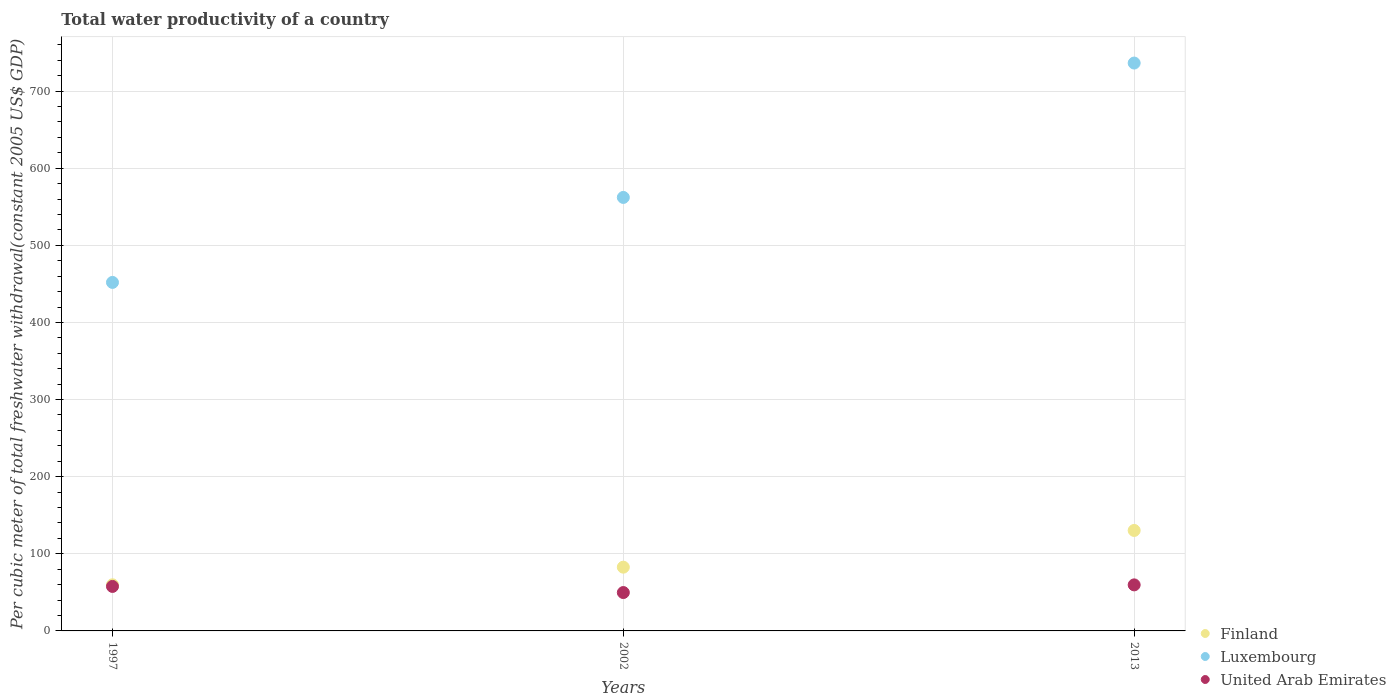What is the total water productivity in Luxembourg in 1997?
Offer a very short reply. 451.9. Across all years, what is the maximum total water productivity in Luxembourg?
Your response must be concise. 736.35. Across all years, what is the minimum total water productivity in Luxembourg?
Offer a terse response. 451.9. In which year was the total water productivity in Finland minimum?
Provide a short and direct response. 1997. What is the total total water productivity in Luxembourg in the graph?
Your response must be concise. 1750.35. What is the difference between the total water productivity in Luxembourg in 1997 and that in 2013?
Provide a short and direct response. -284.44. What is the difference between the total water productivity in Finland in 2013 and the total water productivity in United Arab Emirates in 1997?
Keep it short and to the point. 72.58. What is the average total water productivity in Luxembourg per year?
Provide a short and direct response. 583.45. In the year 1997, what is the difference between the total water productivity in Finland and total water productivity in United Arab Emirates?
Offer a terse response. 2.12. What is the ratio of the total water productivity in Luxembourg in 1997 to that in 2002?
Give a very brief answer. 0.8. What is the difference between the highest and the second highest total water productivity in Luxembourg?
Your answer should be very brief. 174.24. What is the difference between the highest and the lowest total water productivity in United Arab Emirates?
Offer a very short reply. 9.94. Is the sum of the total water productivity in Finland in 2002 and 2013 greater than the maximum total water productivity in United Arab Emirates across all years?
Keep it short and to the point. Yes. Is the total water productivity in Finland strictly greater than the total water productivity in United Arab Emirates over the years?
Your answer should be very brief. Yes. How many dotlines are there?
Ensure brevity in your answer.  3. What is the difference between two consecutive major ticks on the Y-axis?
Your response must be concise. 100. Does the graph contain grids?
Keep it short and to the point. Yes. How many legend labels are there?
Ensure brevity in your answer.  3. How are the legend labels stacked?
Provide a succinct answer. Vertical. What is the title of the graph?
Keep it short and to the point. Total water productivity of a country. Does "Uruguay" appear as one of the legend labels in the graph?
Ensure brevity in your answer.  No. What is the label or title of the X-axis?
Ensure brevity in your answer.  Years. What is the label or title of the Y-axis?
Your answer should be very brief. Per cubic meter of total freshwater withdrawal(constant 2005 US$ GDP). What is the Per cubic meter of total freshwater withdrawal(constant 2005 US$ GDP) of Finland in 1997?
Offer a terse response. 59.81. What is the Per cubic meter of total freshwater withdrawal(constant 2005 US$ GDP) in Luxembourg in 1997?
Your response must be concise. 451.9. What is the Per cubic meter of total freshwater withdrawal(constant 2005 US$ GDP) in United Arab Emirates in 1997?
Your response must be concise. 57.69. What is the Per cubic meter of total freshwater withdrawal(constant 2005 US$ GDP) in Finland in 2002?
Offer a very short reply. 82.67. What is the Per cubic meter of total freshwater withdrawal(constant 2005 US$ GDP) in Luxembourg in 2002?
Offer a terse response. 562.1. What is the Per cubic meter of total freshwater withdrawal(constant 2005 US$ GDP) of United Arab Emirates in 2002?
Offer a terse response. 49.76. What is the Per cubic meter of total freshwater withdrawal(constant 2005 US$ GDP) in Finland in 2013?
Your answer should be compact. 130.27. What is the Per cubic meter of total freshwater withdrawal(constant 2005 US$ GDP) in Luxembourg in 2013?
Your answer should be compact. 736.35. What is the Per cubic meter of total freshwater withdrawal(constant 2005 US$ GDP) in United Arab Emirates in 2013?
Ensure brevity in your answer.  59.7. Across all years, what is the maximum Per cubic meter of total freshwater withdrawal(constant 2005 US$ GDP) in Finland?
Provide a succinct answer. 130.27. Across all years, what is the maximum Per cubic meter of total freshwater withdrawal(constant 2005 US$ GDP) in Luxembourg?
Your response must be concise. 736.35. Across all years, what is the maximum Per cubic meter of total freshwater withdrawal(constant 2005 US$ GDP) of United Arab Emirates?
Your response must be concise. 59.7. Across all years, what is the minimum Per cubic meter of total freshwater withdrawal(constant 2005 US$ GDP) in Finland?
Your answer should be compact. 59.81. Across all years, what is the minimum Per cubic meter of total freshwater withdrawal(constant 2005 US$ GDP) in Luxembourg?
Make the answer very short. 451.9. Across all years, what is the minimum Per cubic meter of total freshwater withdrawal(constant 2005 US$ GDP) of United Arab Emirates?
Keep it short and to the point. 49.76. What is the total Per cubic meter of total freshwater withdrawal(constant 2005 US$ GDP) of Finland in the graph?
Your response must be concise. 272.75. What is the total Per cubic meter of total freshwater withdrawal(constant 2005 US$ GDP) in Luxembourg in the graph?
Your response must be concise. 1750.35. What is the total Per cubic meter of total freshwater withdrawal(constant 2005 US$ GDP) of United Arab Emirates in the graph?
Make the answer very short. 167.14. What is the difference between the Per cubic meter of total freshwater withdrawal(constant 2005 US$ GDP) of Finland in 1997 and that in 2002?
Your response must be concise. -22.86. What is the difference between the Per cubic meter of total freshwater withdrawal(constant 2005 US$ GDP) in Luxembourg in 1997 and that in 2002?
Your answer should be compact. -110.2. What is the difference between the Per cubic meter of total freshwater withdrawal(constant 2005 US$ GDP) in United Arab Emirates in 1997 and that in 2002?
Provide a short and direct response. 7.93. What is the difference between the Per cubic meter of total freshwater withdrawal(constant 2005 US$ GDP) in Finland in 1997 and that in 2013?
Keep it short and to the point. -70.46. What is the difference between the Per cubic meter of total freshwater withdrawal(constant 2005 US$ GDP) of Luxembourg in 1997 and that in 2013?
Make the answer very short. -284.44. What is the difference between the Per cubic meter of total freshwater withdrawal(constant 2005 US$ GDP) in United Arab Emirates in 1997 and that in 2013?
Provide a short and direct response. -2.01. What is the difference between the Per cubic meter of total freshwater withdrawal(constant 2005 US$ GDP) of Finland in 2002 and that in 2013?
Offer a very short reply. -47.61. What is the difference between the Per cubic meter of total freshwater withdrawal(constant 2005 US$ GDP) of Luxembourg in 2002 and that in 2013?
Your answer should be very brief. -174.24. What is the difference between the Per cubic meter of total freshwater withdrawal(constant 2005 US$ GDP) in United Arab Emirates in 2002 and that in 2013?
Offer a very short reply. -9.94. What is the difference between the Per cubic meter of total freshwater withdrawal(constant 2005 US$ GDP) in Finland in 1997 and the Per cubic meter of total freshwater withdrawal(constant 2005 US$ GDP) in Luxembourg in 2002?
Make the answer very short. -502.29. What is the difference between the Per cubic meter of total freshwater withdrawal(constant 2005 US$ GDP) of Finland in 1997 and the Per cubic meter of total freshwater withdrawal(constant 2005 US$ GDP) of United Arab Emirates in 2002?
Give a very brief answer. 10.05. What is the difference between the Per cubic meter of total freshwater withdrawal(constant 2005 US$ GDP) of Luxembourg in 1997 and the Per cubic meter of total freshwater withdrawal(constant 2005 US$ GDP) of United Arab Emirates in 2002?
Provide a short and direct response. 402.14. What is the difference between the Per cubic meter of total freshwater withdrawal(constant 2005 US$ GDP) in Finland in 1997 and the Per cubic meter of total freshwater withdrawal(constant 2005 US$ GDP) in Luxembourg in 2013?
Your answer should be very brief. -676.54. What is the difference between the Per cubic meter of total freshwater withdrawal(constant 2005 US$ GDP) in Finland in 1997 and the Per cubic meter of total freshwater withdrawal(constant 2005 US$ GDP) in United Arab Emirates in 2013?
Give a very brief answer. 0.11. What is the difference between the Per cubic meter of total freshwater withdrawal(constant 2005 US$ GDP) of Luxembourg in 1997 and the Per cubic meter of total freshwater withdrawal(constant 2005 US$ GDP) of United Arab Emirates in 2013?
Your answer should be very brief. 392.21. What is the difference between the Per cubic meter of total freshwater withdrawal(constant 2005 US$ GDP) of Finland in 2002 and the Per cubic meter of total freshwater withdrawal(constant 2005 US$ GDP) of Luxembourg in 2013?
Give a very brief answer. -653.68. What is the difference between the Per cubic meter of total freshwater withdrawal(constant 2005 US$ GDP) in Finland in 2002 and the Per cubic meter of total freshwater withdrawal(constant 2005 US$ GDP) in United Arab Emirates in 2013?
Provide a short and direct response. 22.97. What is the difference between the Per cubic meter of total freshwater withdrawal(constant 2005 US$ GDP) in Luxembourg in 2002 and the Per cubic meter of total freshwater withdrawal(constant 2005 US$ GDP) in United Arab Emirates in 2013?
Provide a short and direct response. 502.41. What is the average Per cubic meter of total freshwater withdrawal(constant 2005 US$ GDP) of Finland per year?
Make the answer very short. 90.92. What is the average Per cubic meter of total freshwater withdrawal(constant 2005 US$ GDP) of Luxembourg per year?
Your answer should be compact. 583.45. What is the average Per cubic meter of total freshwater withdrawal(constant 2005 US$ GDP) of United Arab Emirates per year?
Provide a short and direct response. 55.71. In the year 1997, what is the difference between the Per cubic meter of total freshwater withdrawal(constant 2005 US$ GDP) in Finland and Per cubic meter of total freshwater withdrawal(constant 2005 US$ GDP) in Luxembourg?
Offer a very short reply. -392.09. In the year 1997, what is the difference between the Per cubic meter of total freshwater withdrawal(constant 2005 US$ GDP) of Finland and Per cubic meter of total freshwater withdrawal(constant 2005 US$ GDP) of United Arab Emirates?
Offer a very short reply. 2.12. In the year 1997, what is the difference between the Per cubic meter of total freshwater withdrawal(constant 2005 US$ GDP) in Luxembourg and Per cubic meter of total freshwater withdrawal(constant 2005 US$ GDP) in United Arab Emirates?
Give a very brief answer. 394.22. In the year 2002, what is the difference between the Per cubic meter of total freshwater withdrawal(constant 2005 US$ GDP) in Finland and Per cubic meter of total freshwater withdrawal(constant 2005 US$ GDP) in Luxembourg?
Keep it short and to the point. -479.44. In the year 2002, what is the difference between the Per cubic meter of total freshwater withdrawal(constant 2005 US$ GDP) of Finland and Per cubic meter of total freshwater withdrawal(constant 2005 US$ GDP) of United Arab Emirates?
Your answer should be very brief. 32.91. In the year 2002, what is the difference between the Per cubic meter of total freshwater withdrawal(constant 2005 US$ GDP) in Luxembourg and Per cubic meter of total freshwater withdrawal(constant 2005 US$ GDP) in United Arab Emirates?
Your response must be concise. 512.35. In the year 2013, what is the difference between the Per cubic meter of total freshwater withdrawal(constant 2005 US$ GDP) of Finland and Per cubic meter of total freshwater withdrawal(constant 2005 US$ GDP) of Luxembourg?
Your answer should be compact. -606.08. In the year 2013, what is the difference between the Per cubic meter of total freshwater withdrawal(constant 2005 US$ GDP) of Finland and Per cubic meter of total freshwater withdrawal(constant 2005 US$ GDP) of United Arab Emirates?
Provide a short and direct response. 70.57. In the year 2013, what is the difference between the Per cubic meter of total freshwater withdrawal(constant 2005 US$ GDP) of Luxembourg and Per cubic meter of total freshwater withdrawal(constant 2005 US$ GDP) of United Arab Emirates?
Provide a short and direct response. 676.65. What is the ratio of the Per cubic meter of total freshwater withdrawal(constant 2005 US$ GDP) of Finland in 1997 to that in 2002?
Your response must be concise. 0.72. What is the ratio of the Per cubic meter of total freshwater withdrawal(constant 2005 US$ GDP) in Luxembourg in 1997 to that in 2002?
Your answer should be very brief. 0.8. What is the ratio of the Per cubic meter of total freshwater withdrawal(constant 2005 US$ GDP) of United Arab Emirates in 1997 to that in 2002?
Give a very brief answer. 1.16. What is the ratio of the Per cubic meter of total freshwater withdrawal(constant 2005 US$ GDP) of Finland in 1997 to that in 2013?
Your answer should be compact. 0.46. What is the ratio of the Per cubic meter of total freshwater withdrawal(constant 2005 US$ GDP) of Luxembourg in 1997 to that in 2013?
Provide a short and direct response. 0.61. What is the ratio of the Per cubic meter of total freshwater withdrawal(constant 2005 US$ GDP) of United Arab Emirates in 1997 to that in 2013?
Provide a short and direct response. 0.97. What is the ratio of the Per cubic meter of total freshwater withdrawal(constant 2005 US$ GDP) in Finland in 2002 to that in 2013?
Keep it short and to the point. 0.63. What is the ratio of the Per cubic meter of total freshwater withdrawal(constant 2005 US$ GDP) in Luxembourg in 2002 to that in 2013?
Keep it short and to the point. 0.76. What is the ratio of the Per cubic meter of total freshwater withdrawal(constant 2005 US$ GDP) in United Arab Emirates in 2002 to that in 2013?
Offer a very short reply. 0.83. What is the difference between the highest and the second highest Per cubic meter of total freshwater withdrawal(constant 2005 US$ GDP) of Finland?
Offer a terse response. 47.61. What is the difference between the highest and the second highest Per cubic meter of total freshwater withdrawal(constant 2005 US$ GDP) of Luxembourg?
Your response must be concise. 174.24. What is the difference between the highest and the second highest Per cubic meter of total freshwater withdrawal(constant 2005 US$ GDP) in United Arab Emirates?
Your response must be concise. 2.01. What is the difference between the highest and the lowest Per cubic meter of total freshwater withdrawal(constant 2005 US$ GDP) of Finland?
Ensure brevity in your answer.  70.46. What is the difference between the highest and the lowest Per cubic meter of total freshwater withdrawal(constant 2005 US$ GDP) of Luxembourg?
Provide a succinct answer. 284.44. What is the difference between the highest and the lowest Per cubic meter of total freshwater withdrawal(constant 2005 US$ GDP) in United Arab Emirates?
Your answer should be compact. 9.94. 